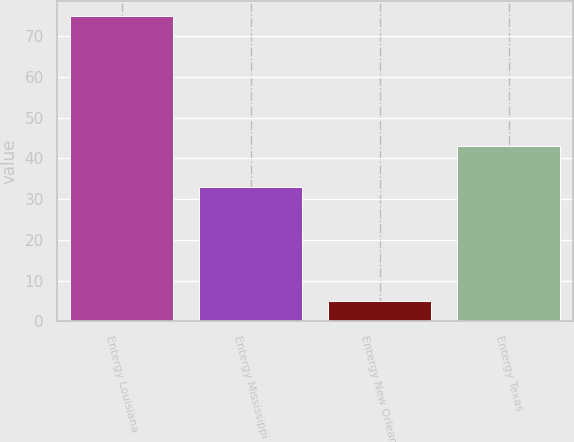Convert chart to OTSL. <chart><loc_0><loc_0><loc_500><loc_500><bar_chart><fcel>Entergy Louisiana<fcel>Entergy Mississippi<fcel>Entergy New Orleans<fcel>Entergy Texas<nl><fcel>75<fcel>33<fcel>5<fcel>43<nl></chart> 